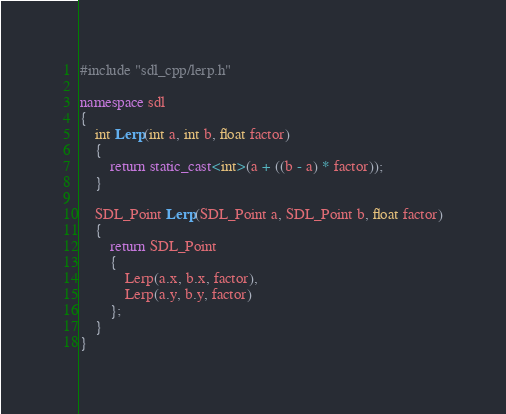<code> <loc_0><loc_0><loc_500><loc_500><_C++_>#include "sdl_cpp/lerp.h"

namespace sdl
{
	int Lerp(int a, int b, float factor)
	{
		return static_cast<int>(a + ((b - a) * factor));
	}

	SDL_Point Lerp(SDL_Point a, SDL_Point b, float factor)
	{
		return SDL_Point
		{
			Lerp(a.x, b.x, factor),
			Lerp(a.y, b.y, factor)
		};
	}
}
</code> 